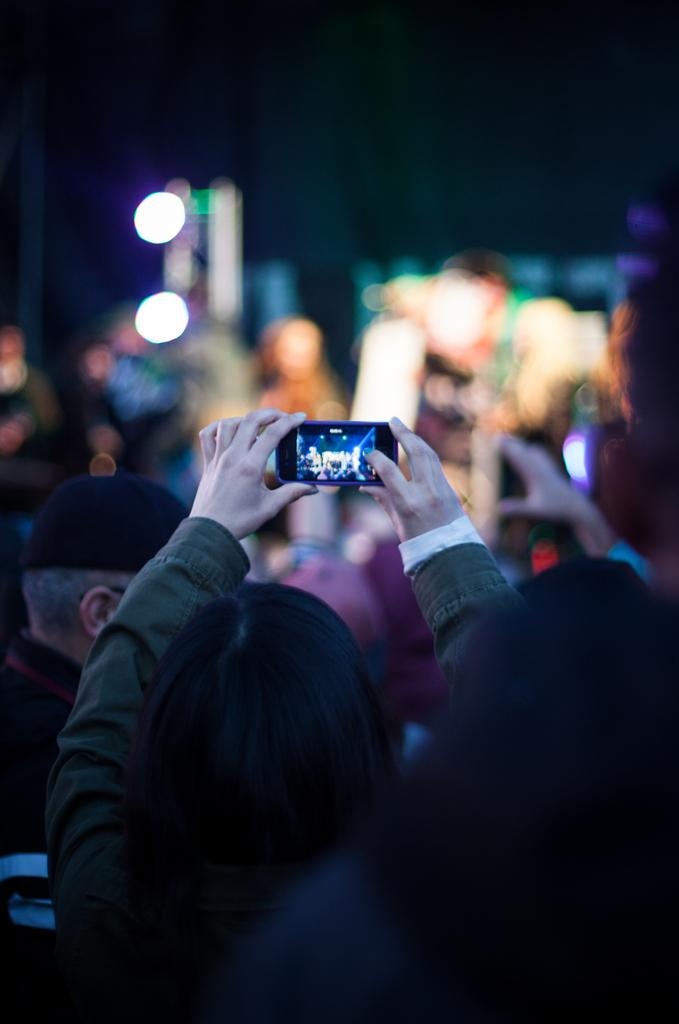Who is the main subject in the image? There is a woman in the image. What is the woman holding in the image? The woman is holding a mobile phone. What is the woman doing with the mobile phone? The woman is clicking a picture. Can you describe the person standing in front of the woman? There is a person standing in front of the woman, but their appearance or characteristics are not mentioned in the facts. What type of sofa can be seen in the background of the image? There is no sofa present in the image. Can you describe the jellyfish swimming near the woman in the image? There are no jellyfish present in the image. 